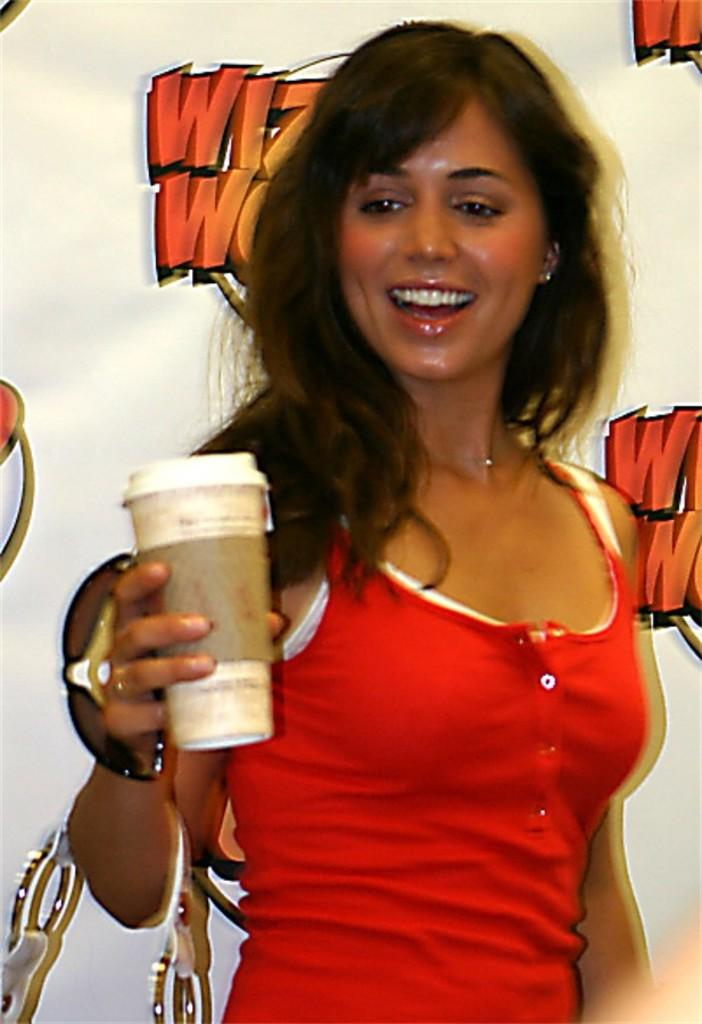Who is present in the image? There is a woman in the image. What is the woman holding in the image? The woman is holding a cup. What can be seen in the background of the image? There is a banner in the background of the image. What information is provided on the banner? The banner has text on it. What type of design is present on the banner? The banner has a design on it. What type of argument is the woman having with the police in the image? There is no argument or police present in the image; it only features a woman holding a cup and a banner in the background. 